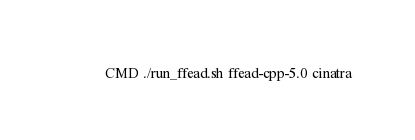<code> <loc_0><loc_0><loc_500><loc_500><_Dockerfile_>CMD ./run_ffead.sh ffead-cpp-5.0 cinatra
</code> 